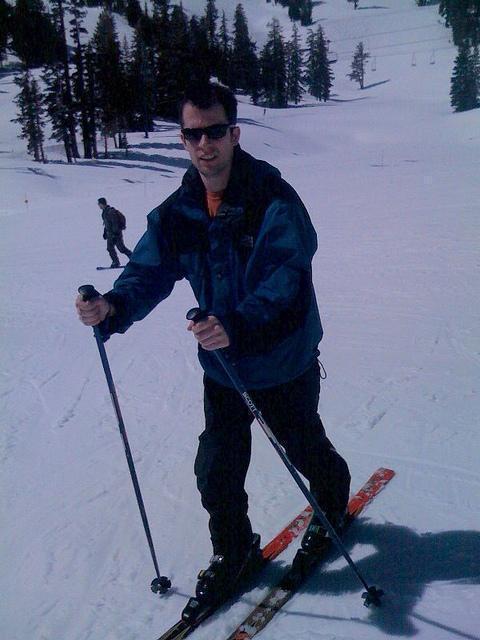What is the man in the foreground balancing with?
Choose the right answer from the provided options to respond to the question.
Options: Ski poles, bannister, rope, hook. Ski poles. 